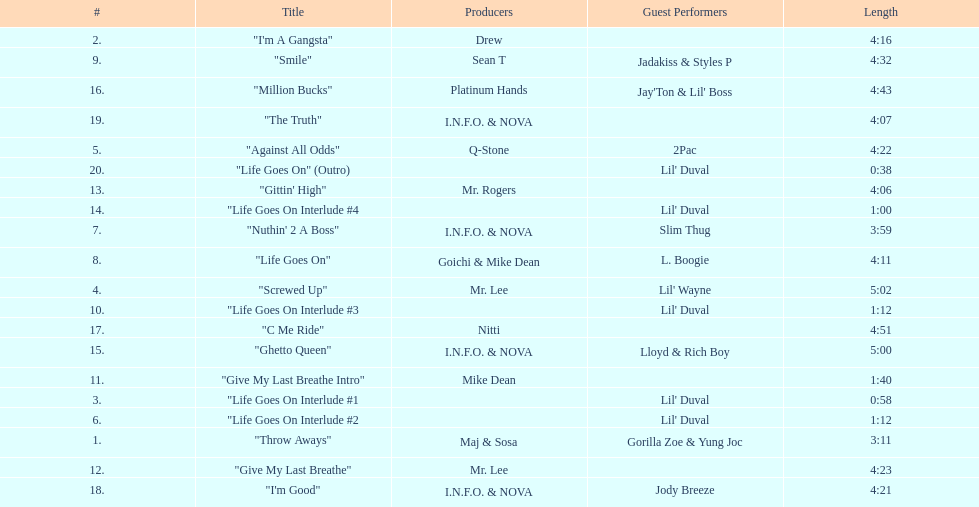What is the longest track on the album? "Screwed Up". 